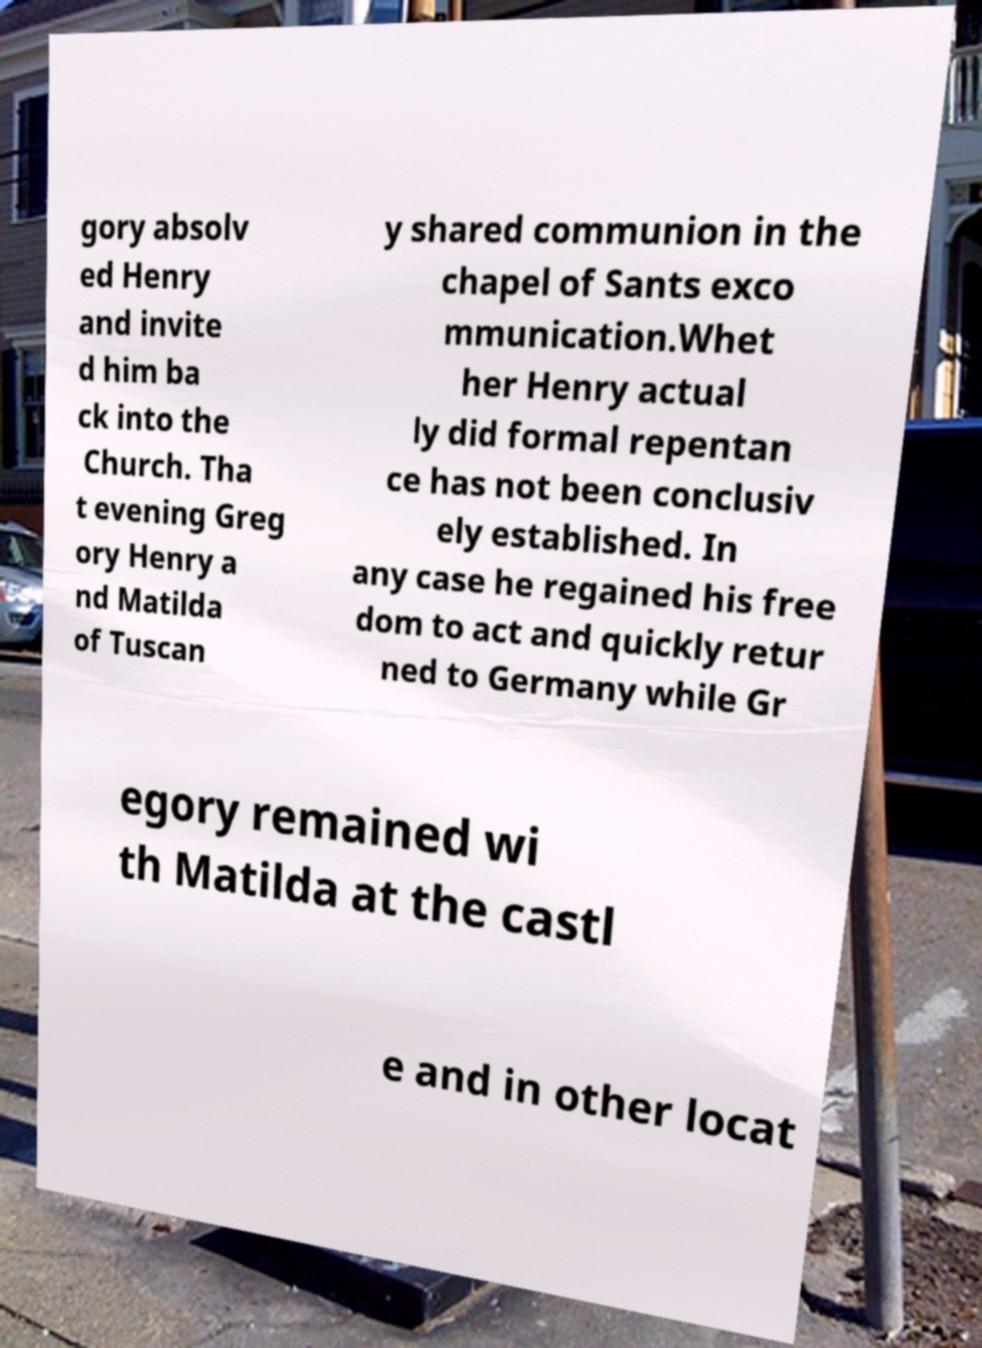Can you read and provide the text displayed in the image?This photo seems to have some interesting text. Can you extract and type it out for me? gory absolv ed Henry and invite d him ba ck into the Church. Tha t evening Greg ory Henry a nd Matilda of Tuscan y shared communion in the chapel of Sants exco mmunication.Whet her Henry actual ly did formal repentan ce has not been conclusiv ely established. In any case he regained his free dom to act and quickly retur ned to Germany while Gr egory remained wi th Matilda at the castl e and in other locat 